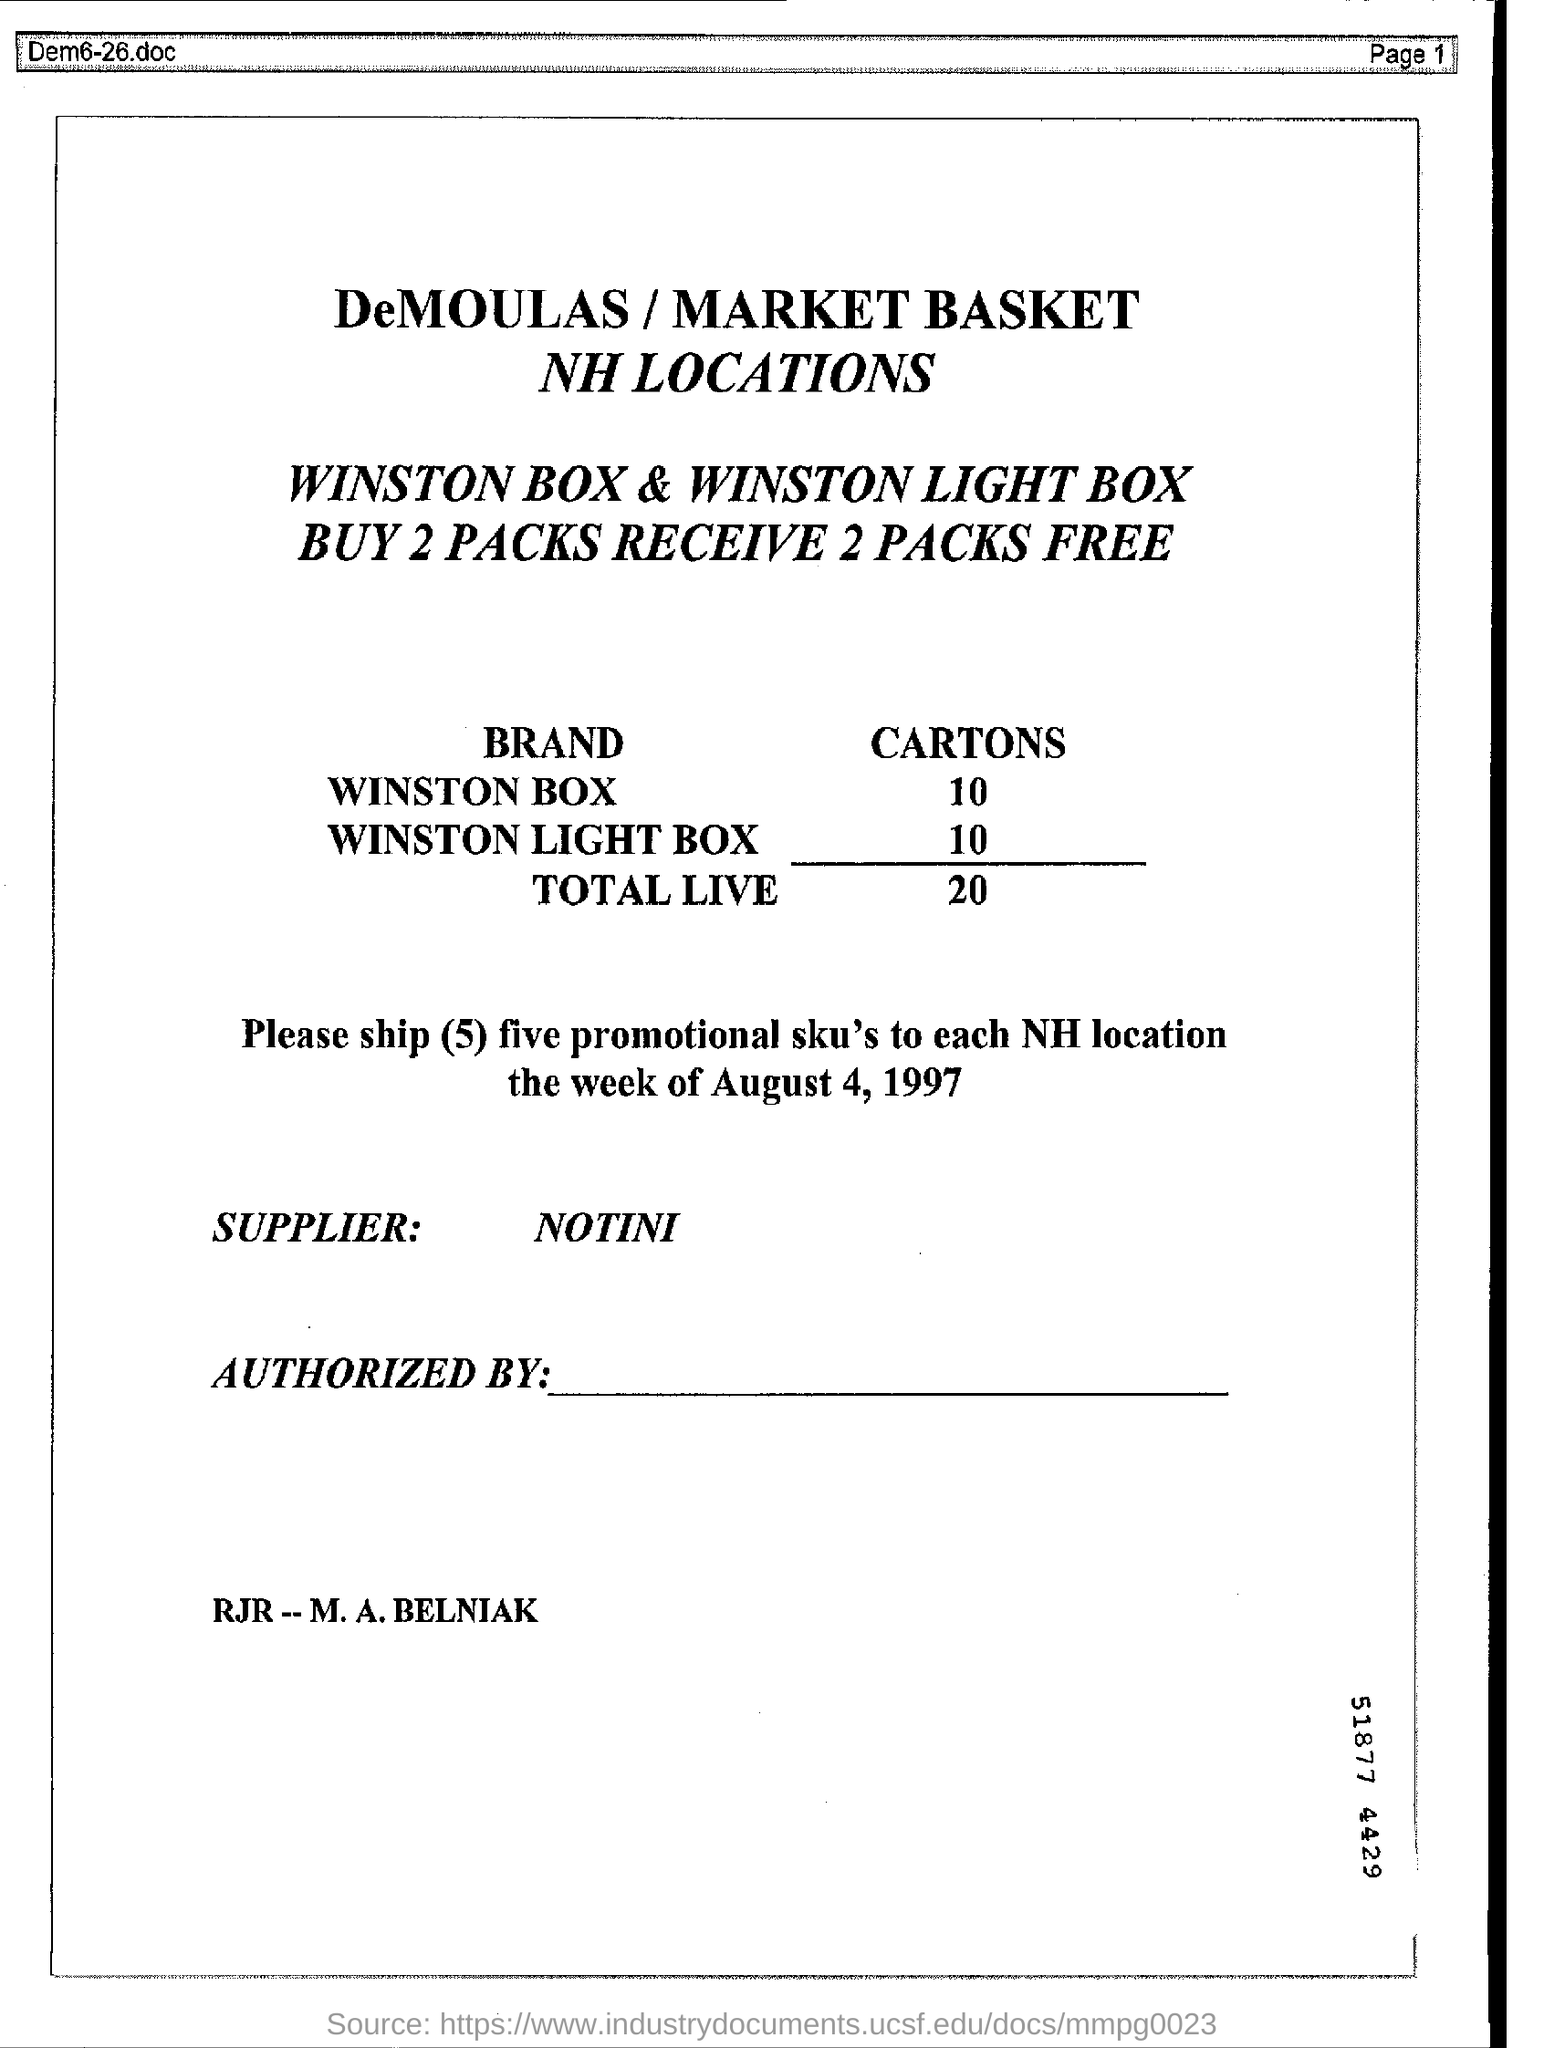Draw attention to some important aspects in this diagram. I am not providing the name of a specific supplier. We need 10 boxes of WINSTON cigarettes. The number of cartons of WINSTON LIGHT BOX is 10. 